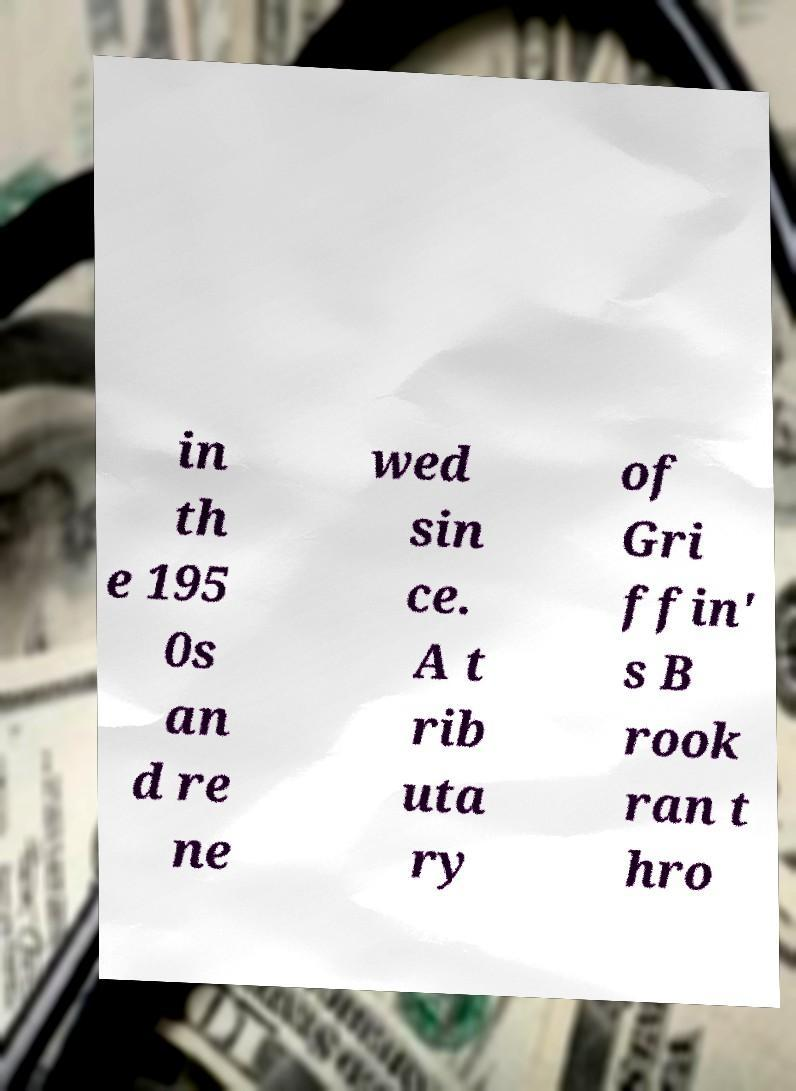Please read and relay the text visible in this image. What does it say? in th e 195 0s an d re ne wed sin ce. A t rib uta ry of Gri ffin' s B rook ran t hro 